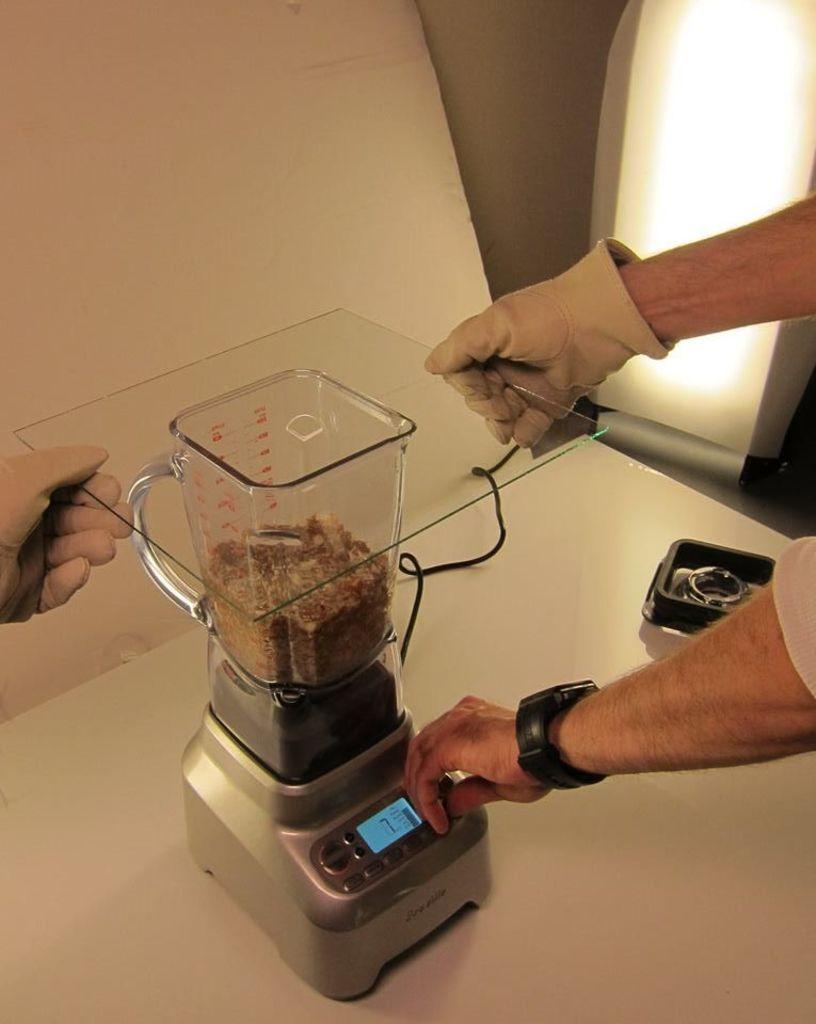How would you summarize this image in a sentence or two? In this image we can see two persons wearing gloves and holding a glass sheet in their hand. One person is operating a mixer grinder placed on the table. In the background ,we can see a box and a light bulb. 